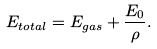<formula> <loc_0><loc_0><loc_500><loc_500>E _ { t o t a l } = E _ { g a s } + \frac { E _ { 0 } } { \rho } .</formula> 